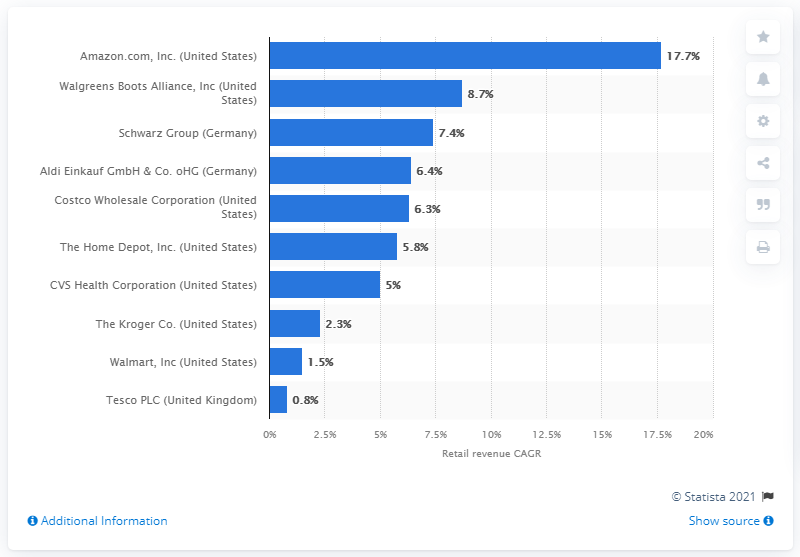Outline some significant characteristics in this image. Walmart's retail revenue CAGR between 2014 and 2019 was 1.5%. During the period between 2014 and 2019, the Compound Annual Growth Rate (CAGR) of Amazon.com was 17.7%. 